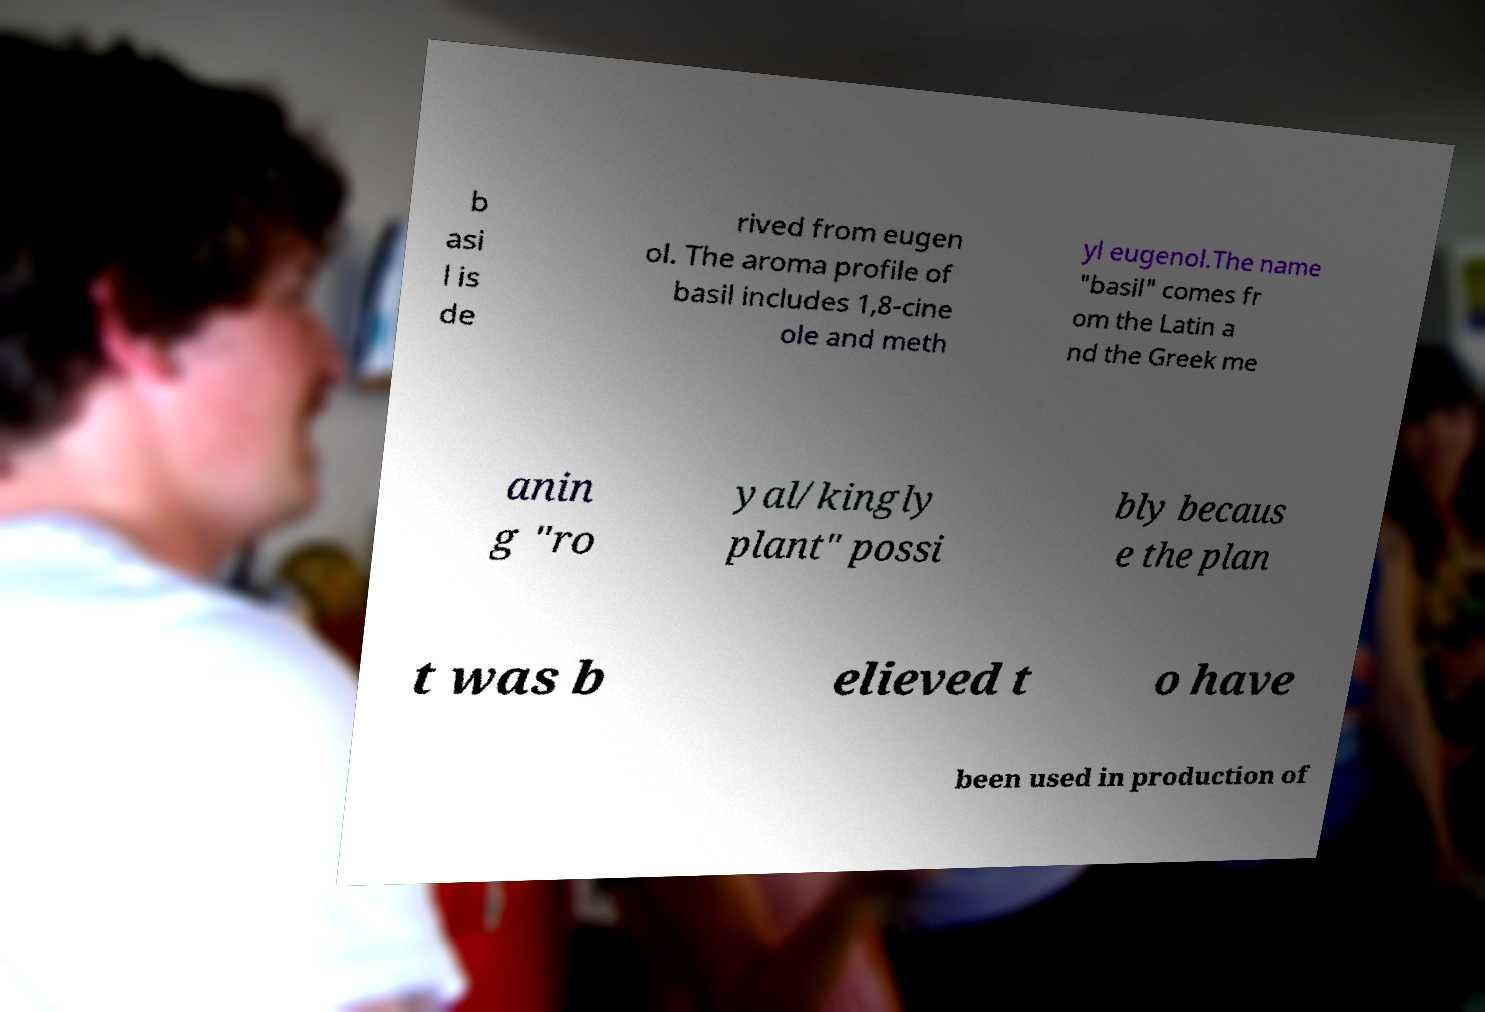Please identify and transcribe the text found in this image. b asi l is de rived from eugen ol. The aroma profile of basil includes 1,8-cine ole and meth yl eugenol.The name "basil" comes fr om the Latin a nd the Greek me anin g "ro yal/kingly plant" possi bly becaus e the plan t was b elieved t o have been used in production of 